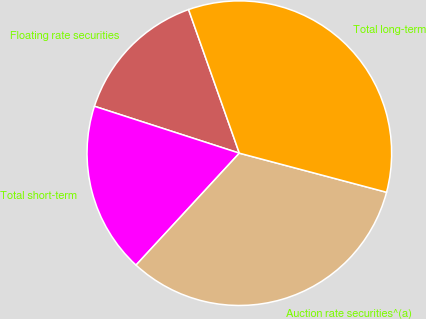Convert chart. <chart><loc_0><loc_0><loc_500><loc_500><pie_chart><fcel>Floating rate securities<fcel>Total short-term<fcel>Auction rate securities^(a)<fcel>Total long-term<nl><fcel>14.61%<fcel>18.12%<fcel>32.73%<fcel>34.54%<nl></chart> 